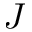Convert formula to latex. <formula><loc_0><loc_0><loc_500><loc_500>J</formula> 